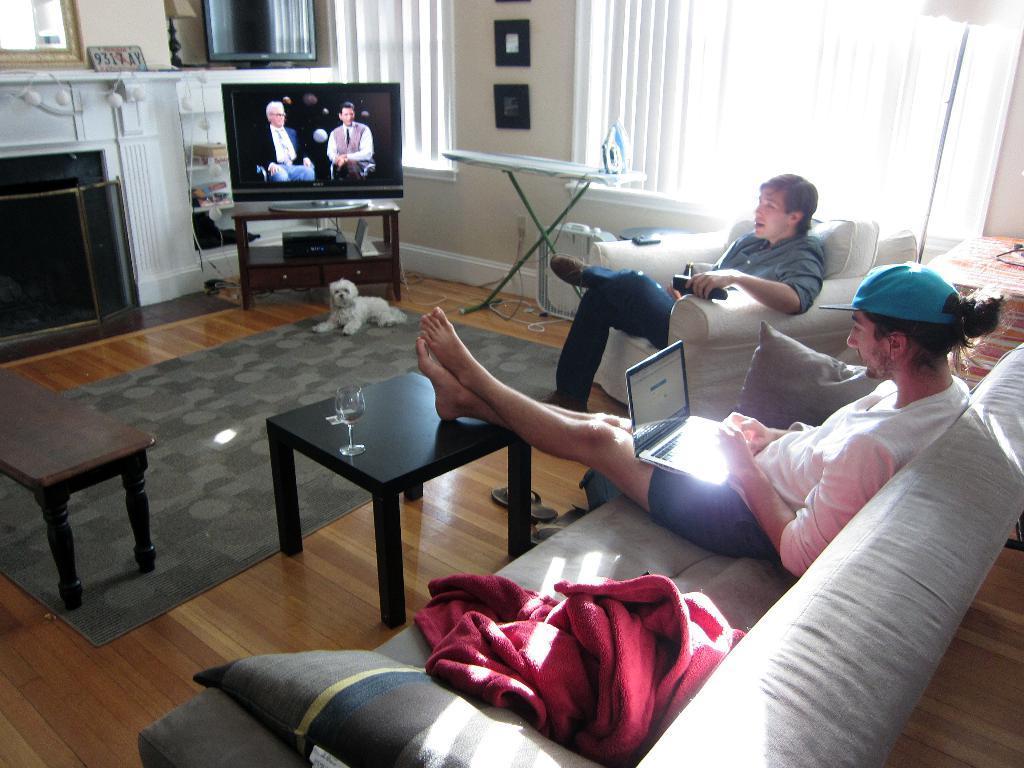In one or two sentences, can you explain what this image depicts? There are two men sitting on the chair,one is holding remote and the other is working on laptop. In this room there is TV on a table,iron box and with stand,window,curtain and frames on the wall. 